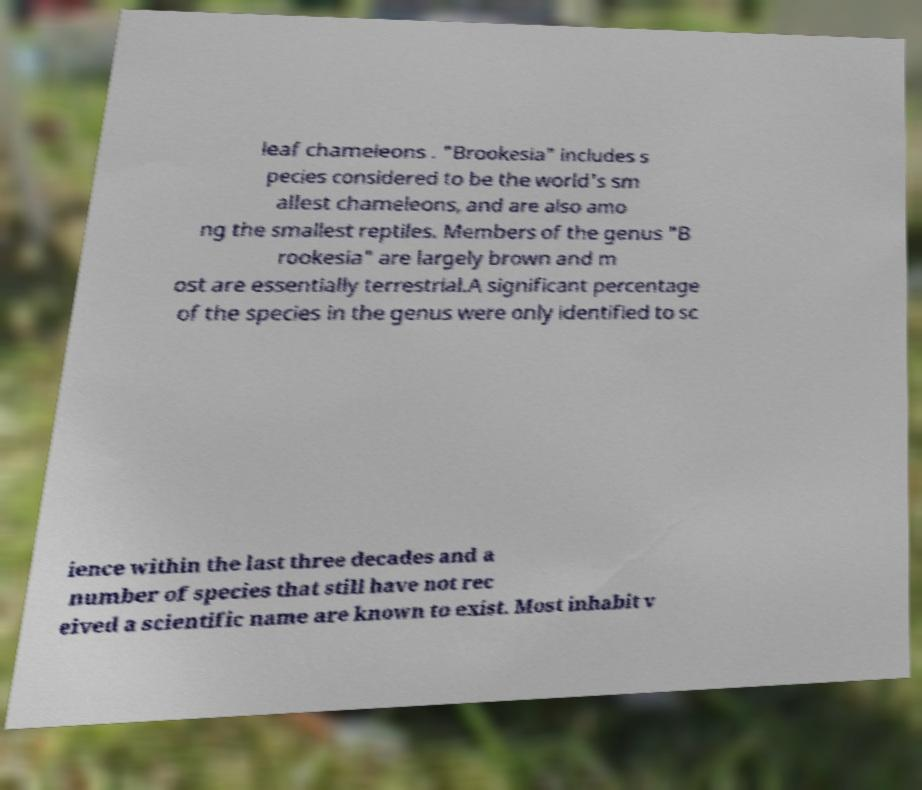Please read and relay the text visible in this image. What does it say? leaf chameleons . "Brookesia" includes s pecies considered to be the world's sm allest chameleons, and are also amo ng the smallest reptiles. Members of the genus "B rookesia" are largely brown and m ost are essentially terrestrial.A significant percentage of the species in the genus were only identified to sc ience within the last three decades and a number of species that still have not rec eived a scientific name are known to exist. Most inhabit v 